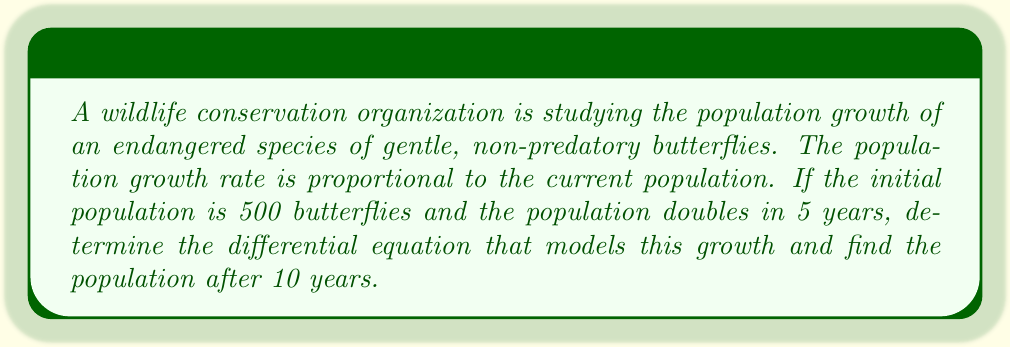Teach me how to tackle this problem. Let's approach this step-by-step:

1) Let $P(t)$ be the population at time $t$ (in years).

2) Given that the growth rate is proportional to the current population, we can express this as:

   $$\frac{dP}{dt} = kP$$

   where $k$ is the growth constant.

3) We're told that $P(0) = 500$ (initial population) and $P(5) = 1000$ (population doubles in 5 years).

4) The solution to this differential equation is:

   $$P(t) = P(0)e^{kt}$$

5) Using the condition $P(5) = 1000$:

   $$1000 = 500e^{5k}$$

6) Solving for $k$:

   $$e^{5k} = 2$$
   $$5k = \ln(2)$$
   $$k = \frac{\ln(2)}{5}$$

7) Therefore, the differential equation that models this growth is:

   $$\frac{dP}{dt} = \frac{\ln(2)}{5}P$$

8) To find the population after 10 years, we use:

   $$P(10) = 500e^{\frac{\ln(2)}{5}10} = 500e^{2\ln(2)} = 500(2^2) = 2000$$
Answer: The differential equation is $\frac{dP}{dt} = \frac{\ln(2)}{5}P$, and the population after 10 years is 2000 butterflies. 